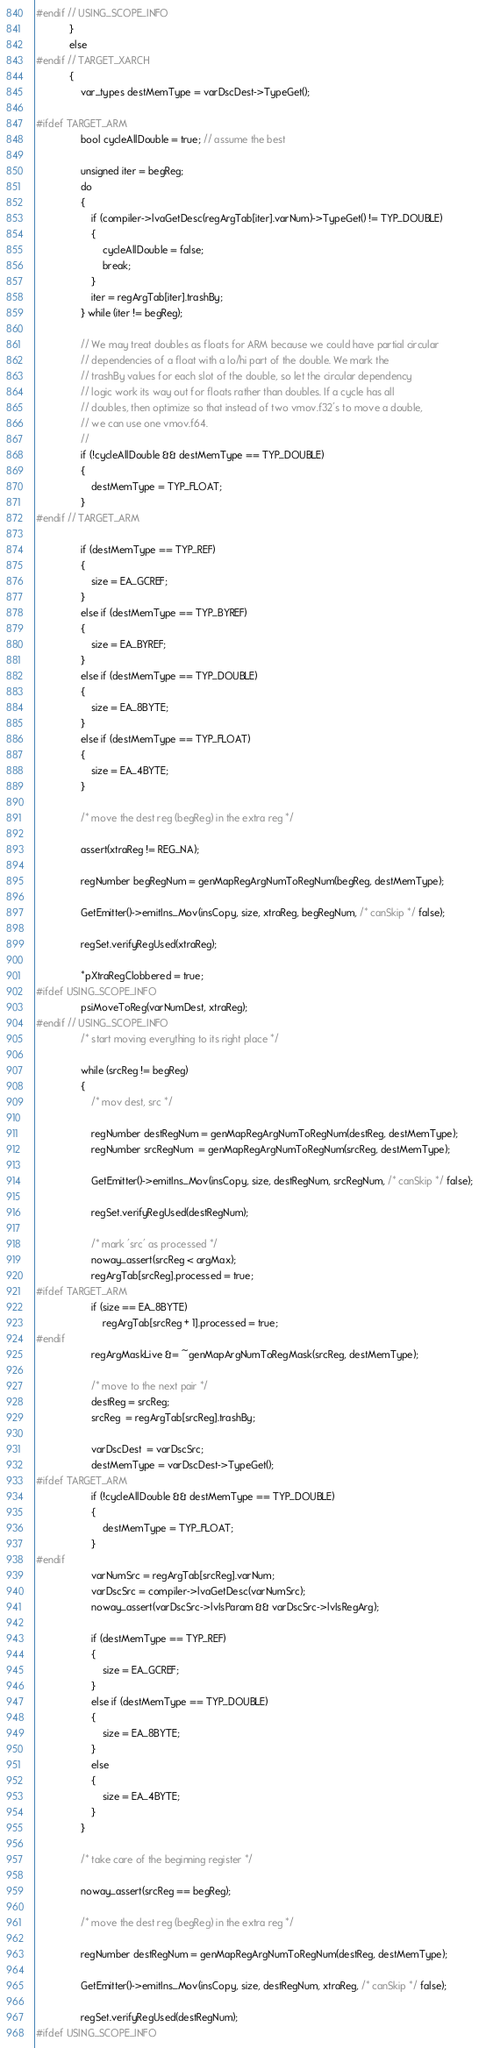Convert code to text. <code><loc_0><loc_0><loc_500><loc_500><_C++_>#endif // USING_SCOPE_INFO
            }
            else
#endif // TARGET_XARCH
            {
                var_types destMemType = varDscDest->TypeGet();

#ifdef TARGET_ARM
                bool cycleAllDouble = true; // assume the best

                unsigned iter = begReg;
                do
                {
                    if (compiler->lvaGetDesc(regArgTab[iter].varNum)->TypeGet() != TYP_DOUBLE)
                    {
                        cycleAllDouble = false;
                        break;
                    }
                    iter = regArgTab[iter].trashBy;
                } while (iter != begReg);

                // We may treat doubles as floats for ARM because we could have partial circular
                // dependencies of a float with a lo/hi part of the double. We mark the
                // trashBy values for each slot of the double, so let the circular dependency
                // logic work its way out for floats rather than doubles. If a cycle has all
                // doubles, then optimize so that instead of two vmov.f32's to move a double,
                // we can use one vmov.f64.
                //
                if (!cycleAllDouble && destMemType == TYP_DOUBLE)
                {
                    destMemType = TYP_FLOAT;
                }
#endif // TARGET_ARM

                if (destMemType == TYP_REF)
                {
                    size = EA_GCREF;
                }
                else if (destMemType == TYP_BYREF)
                {
                    size = EA_BYREF;
                }
                else if (destMemType == TYP_DOUBLE)
                {
                    size = EA_8BYTE;
                }
                else if (destMemType == TYP_FLOAT)
                {
                    size = EA_4BYTE;
                }

                /* move the dest reg (begReg) in the extra reg */

                assert(xtraReg != REG_NA);

                regNumber begRegNum = genMapRegArgNumToRegNum(begReg, destMemType);

                GetEmitter()->emitIns_Mov(insCopy, size, xtraReg, begRegNum, /* canSkip */ false);

                regSet.verifyRegUsed(xtraReg);

                *pXtraRegClobbered = true;
#ifdef USING_SCOPE_INFO
                psiMoveToReg(varNumDest, xtraReg);
#endif // USING_SCOPE_INFO
                /* start moving everything to its right place */

                while (srcReg != begReg)
                {
                    /* mov dest, src */

                    regNumber destRegNum = genMapRegArgNumToRegNum(destReg, destMemType);
                    regNumber srcRegNum  = genMapRegArgNumToRegNum(srcReg, destMemType);

                    GetEmitter()->emitIns_Mov(insCopy, size, destRegNum, srcRegNum, /* canSkip */ false);

                    regSet.verifyRegUsed(destRegNum);

                    /* mark 'src' as processed */
                    noway_assert(srcReg < argMax);
                    regArgTab[srcReg].processed = true;
#ifdef TARGET_ARM
                    if (size == EA_8BYTE)
                        regArgTab[srcReg + 1].processed = true;
#endif
                    regArgMaskLive &= ~genMapArgNumToRegMask(srcReg, destMemType);

                    /* move to the next pair */
                    destReg = srcReg;
                    srcReg  = regArgTab[srcReg].trashBy;

                    varDscDest  = varDscSrc;
                    destMemType = varDscDest->TypeGet();
#ifdef TARGET_ARM
                    if (!cycleAllDouble && destMemType == TYP_DOUBLE)
                    {
                        destMemType = TYP_FLOAT;
                    }
#endif
                    varNumSrc = regArgTab[srcReg].varNum;
                    varDscSrc = compiler->lvaGetDesc(varNumSrc);
                    noway_assert(varDscSrc->lvIsParam && varDscSrc->lvIsRegArg);

                    if (destMemType == TYP_REF)
                    {
                        size = EA_GCREF;
                    }
                    else if (destMemType == TYP_DOUBLE)
                    {
                        size = EA_8BYTE;
                    }
                    else
                    {
                        size = EA_4BYTE;
                    }
                }

                /* take care of the beginning register */

                noway_assert(srcReg == begReg);

                /* move the dest reg (begReg) in the extra reg */

                regNumber destRegNum = genMapRegArgNumToRegNum(destReg, destMemType);

                GetEmitter()->emitIns_Mov(insCopy, size, destRegNum, xtraReg, /* canSkip */ false);

                regSet.verifyRegUsed(destRegNum);
#ifdef USING_SCOPE_INFO</code> 